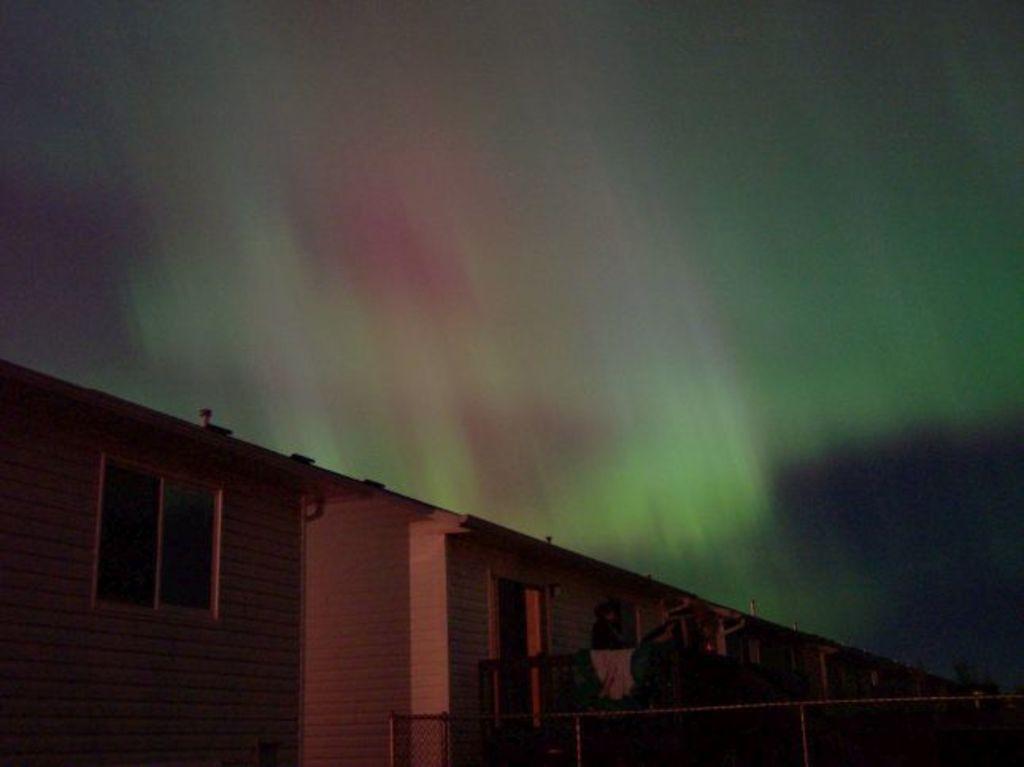Please provide a concise description of this image. As we can see in the image there are buildings, fence and sky. 